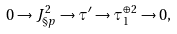Convert formula to latex. <formula><loc_0><loc_0><loc_500><loc_500>0 \rightarrow J ^ { 2 } _ { \S p } \rightarrow \tau ^ { \prime } \rightarrow \tau _ { 1 } ^ { \oplus 2 } \rightarrow 0 ,</formula> 